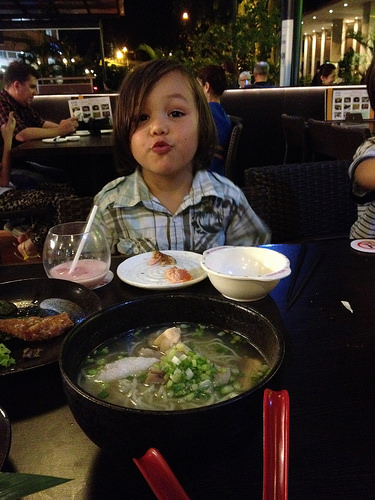<image>
Is there a light behind the child? Yes. From this viewpoint, the light is positioned behind the child, with the child partially or fully occluding the light. 